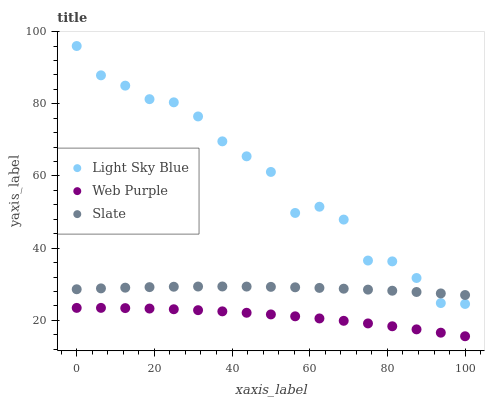Does Web Purple have the minimum area under the curve?
Answer yes or no. Yes. Does Light Sky Blue have the maximum area under the curve?
Answer yes or no. Yes. Does Slate have the minimum area under the curve?
Answer yes or no. No. Does Slate have the maximum area under the curve?
Answer yes or no. No. Is Slate the smoothest?
Answer yes or no. Yes. Is Light Sky Blue the roughest?
Answer yes or no. Yes. Is Light Sky Blue the smoothest?
Answer yes or no. No. Is Slate the roughest?
Answer yes or no. No. Does Web Purple have the lowest value?
Answer yes or no. Yes. Does Light Sky Blue have the lowest value?
Answer yes or no. No. Does Light Sky Blue have the highest value?
Answer yes or no. Yes. Does Slate have the highest value?
Answer yes or no. No. Is Web Purple less than Light Sky Blue?
Answer yes or no. Yes. Is Light Sky Blue greater than Web Purple?
Answer yes or no. Yes. Does Slate intersect Light Sky Blue?
Answer yes or no. Yes. Is Slate less than Light Sky Blue?
Answer yes or no. No. Is Slate greater than Light Sky Blue?
Answer yes or no. No. Does Web Purple intersect Light Sky Blue?
Answer yes or no. No. 